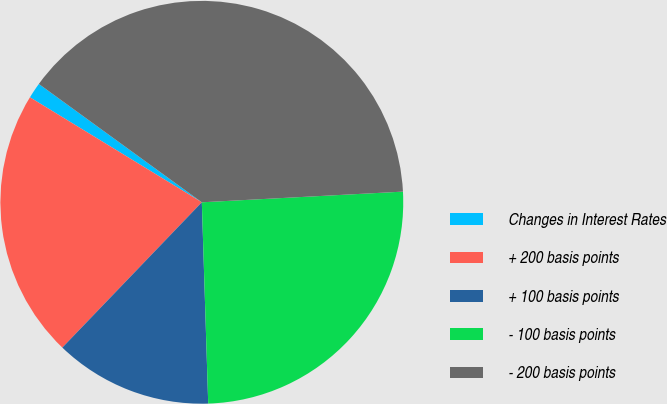<chart> <loc_0><loc_0><loc_500><loc_500><pie_chart><fcel>Changes in Interest Rates<fcel>+ 200 basis points<fcel>+ 100 basis points<fcel>- 100 basis points<fcel>- 200 basis points<nl><fcel>1.27%<fcel>21.55%<fcel>12.68%<fcel>25.34%<fcel>39.16%<nl></chart> 